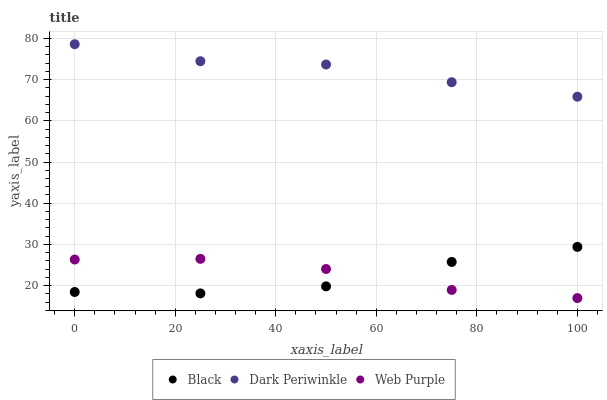Does Black have the minimum area under the curve?
Answer yes or no. Yes. Does Dark Periwinkle have the maximum area under the curve?
Answer yes or no. Yes. Does Dark Periwinkle have the minimum area under the curve?
Answer yes or no. No. Does Black have the maximum area under the curve?
Answer yes or no. No. Is Dark Periwinkle the smoothest?
Answer yes or no. Yes. Is Black the roughest?
Answer yes or no. Yes. Is Black the smoothest?
Answer yes or no. No. Is Dark Periwinkle the roughest?
Answer yes or no. No. Does Web Purple have the lowest value?
Answer yes or no. Yes. Does Black have the lowest value?
Answer yes or no. No. Does Dark Periwinkle have the highest value?
Answer yes or no. Yes. Does Black have the highest value?
Answer yes or no. No. Is Black less than Dark Periwinkle?
Answer yes or no. Yes. Is Dark Periwinkle greater than Black?
Answer yes or no. Yes. Does Web Purple intersect Black?
Answer yes or no. Yes. Is Web Purple less than Black?
Answer yes or no. No. Is Web Purple greater than Black?
Answer yes or no. No. Does Black intersect Dark Periwinkle?
Answer yes or no. No. 